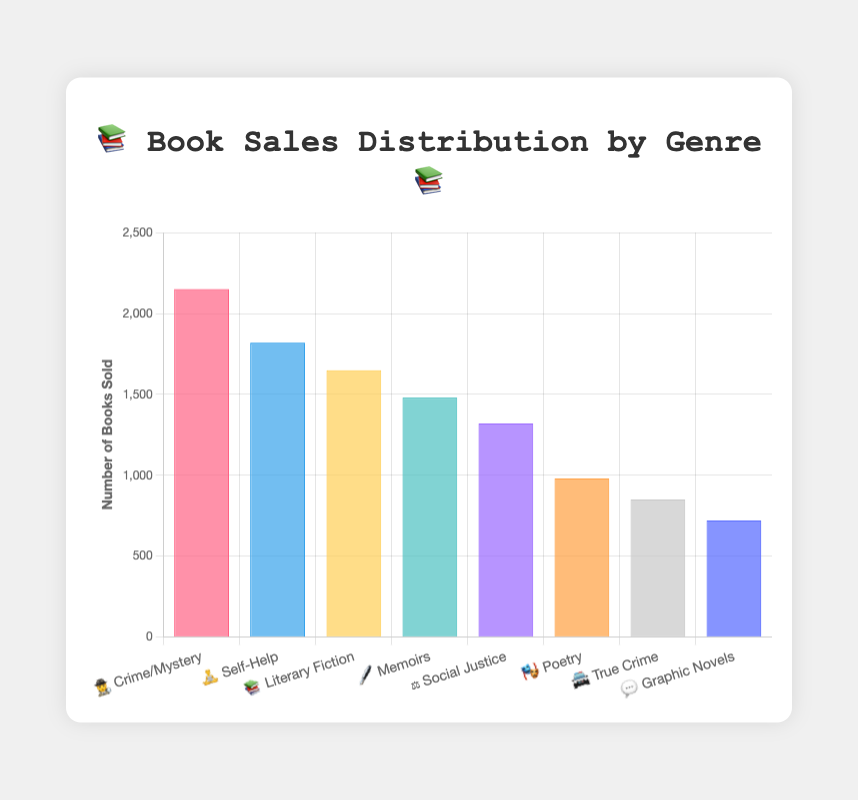What's the most popular book genre based on the sales? The genre with the highest bar indicates the most popular genre by book sales. The "🕵️ Crime/Mystery" bar is the tallest, representing 2150 sales.
Answer: 🕵️ Crime/Mystery Which genre has the lowest book sales? The genre with the shortest bar indicates the fewest sales. The "💬 Graphic Novels" bar is the shortest, representing 720 sales.
Answer: 💬 Graphic Novels How many more books did "🕵️ Crime/Mystery" sell compared to "🎭 Poetry"? Subtract the sales of "🎭 Poetry" (980) from "🕵️ Crime/Mystery" (2150). 2150 - 980 = 1170
Answer: 1170 What are the total book sales for "🖋️ Memoirs" and "⚖️ Social Justice"? Add the sales of "🖋️ Memoirs" (1480) and "⚖️ Social Justice" (1320). 1480 + 1320 = 2800
Answer: 2800 Which genre has higher sales, "📚 Literary Fiction" or "🧘 Self-Help"? Compare their sales: "📚 Literary Fiction" has 1650 sales, and "🧘 Self-Help" has 1820 sales. "🧘 Self-Help" has higher sales.
Answer: 🧘 Self-Help What is the average number of books sold across all genres? Sum all sales and then divide by the number of genres. (2150 + 1820 + 1650 + 1480 + 1320 + 980 + 850 + 720) = 10970; 10970 / 8 = 1371.25
Answer: 1371.25 Which genre is in the middle range of sales? Arrange sales in order: 720, 850, 980, 1320, 1480, 1650, 1820, 2150. The middle values are "🖋️ Memoirs" (1480) and "📚 Literary Fiction" (1650).
Answer: 🖋️ Memoirs & 📚 Literary Fiction (Median: 1480 & 1650) What is the difference in sales between "🚔 True Crime" and "🧘 Self-Help"? Subtract the sales of "🚔 True Crime" (850) from "🧘 Self-Help" (1820). 1820 - 850 = 970
Answer: 970 